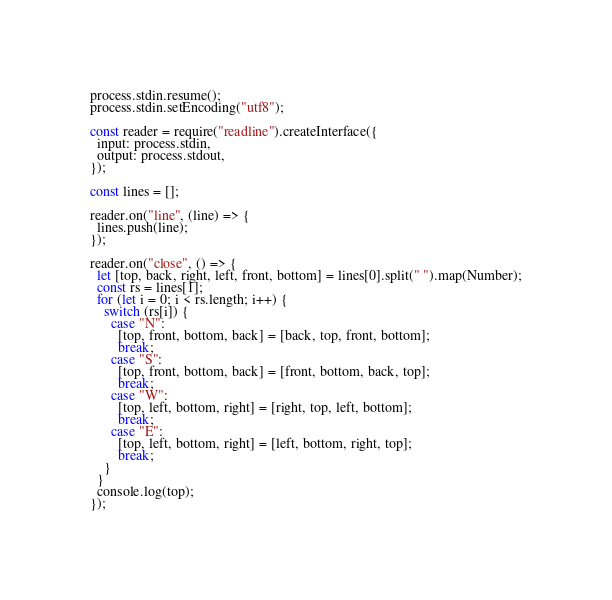<code> <loc_0><loc_0><loc_500><loc_500><_JavaScript_>process.stdin.resume();
process.stdin.setEncoding("utf8");

const reader = require("readline").createInterface({
  input: process.stdin,
  output: process.stdout,
});

const lines = [];

reader.on("line", (line) => {
  lines.push(line);
});

reader.on("close", () => {
  let [top, back, right, left, front, bottom] = lines[0].split(" ").map(Number);
  const rs = lines[1];
  for (let i = 0; i < rs.length; i++) {
    switch (rs[i]) {
      case "N":
        [top, front, bottom, back] = [back, top, front, bottom];
        break;
      case "S":
        [top, front, bottom, back] = [front, bottom, back, top];
        break;
      case "W":
        [top, left, bottom, right] = [right, top, left, bottom];
        break;
      case "E":
        [top, left, bottom, right] = [left, bottom, right, top];
        break;
    }
  }
  console.log(top);
});

</code> 